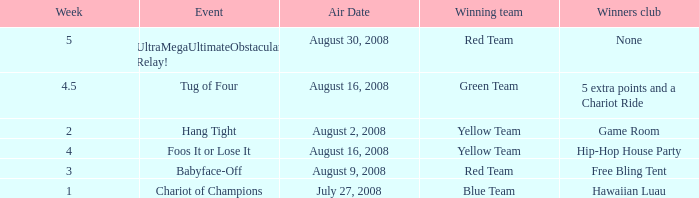How many weeks have a Winning team of yellow team, and an Event of foos it or lose it? 4.0. 